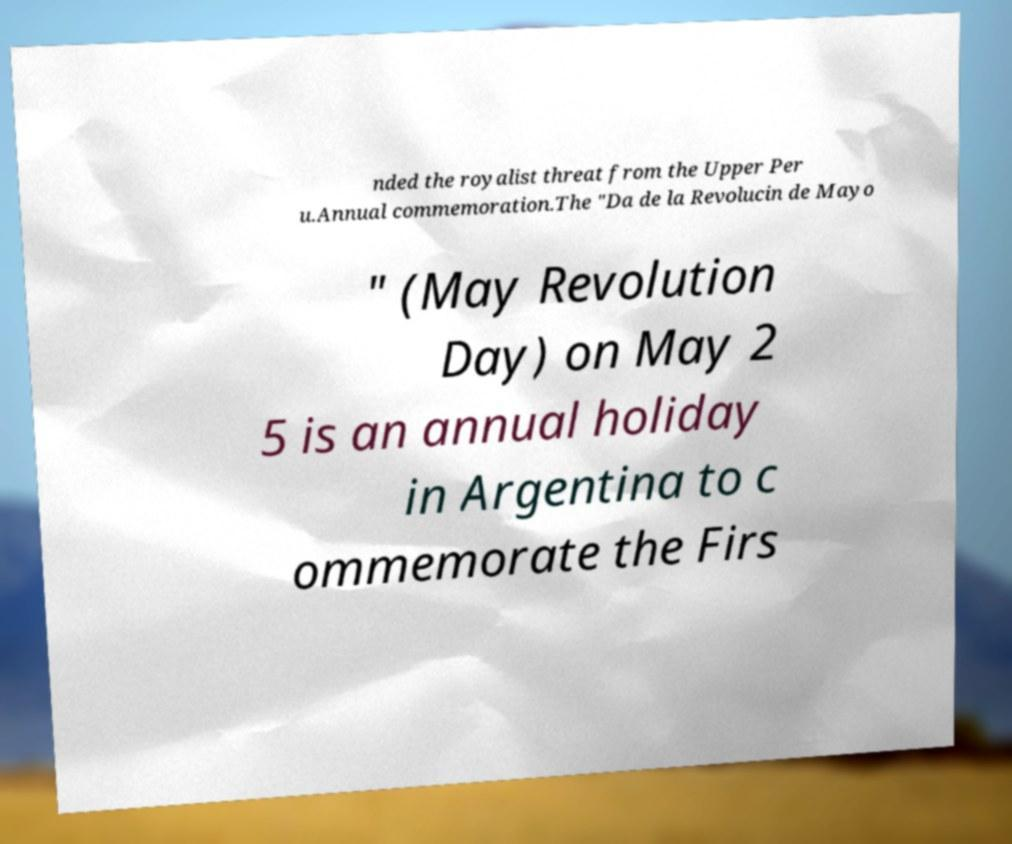Can you accurately transcribe the text from the provided image for me? nded the royalist threat from the Upper Per u.Annual commemoration.The "Da de la Revolucin de Mayo " (May Revolution Day) on May 2 5 is an annual holiday in Argentina to c ommemorate the Firs 